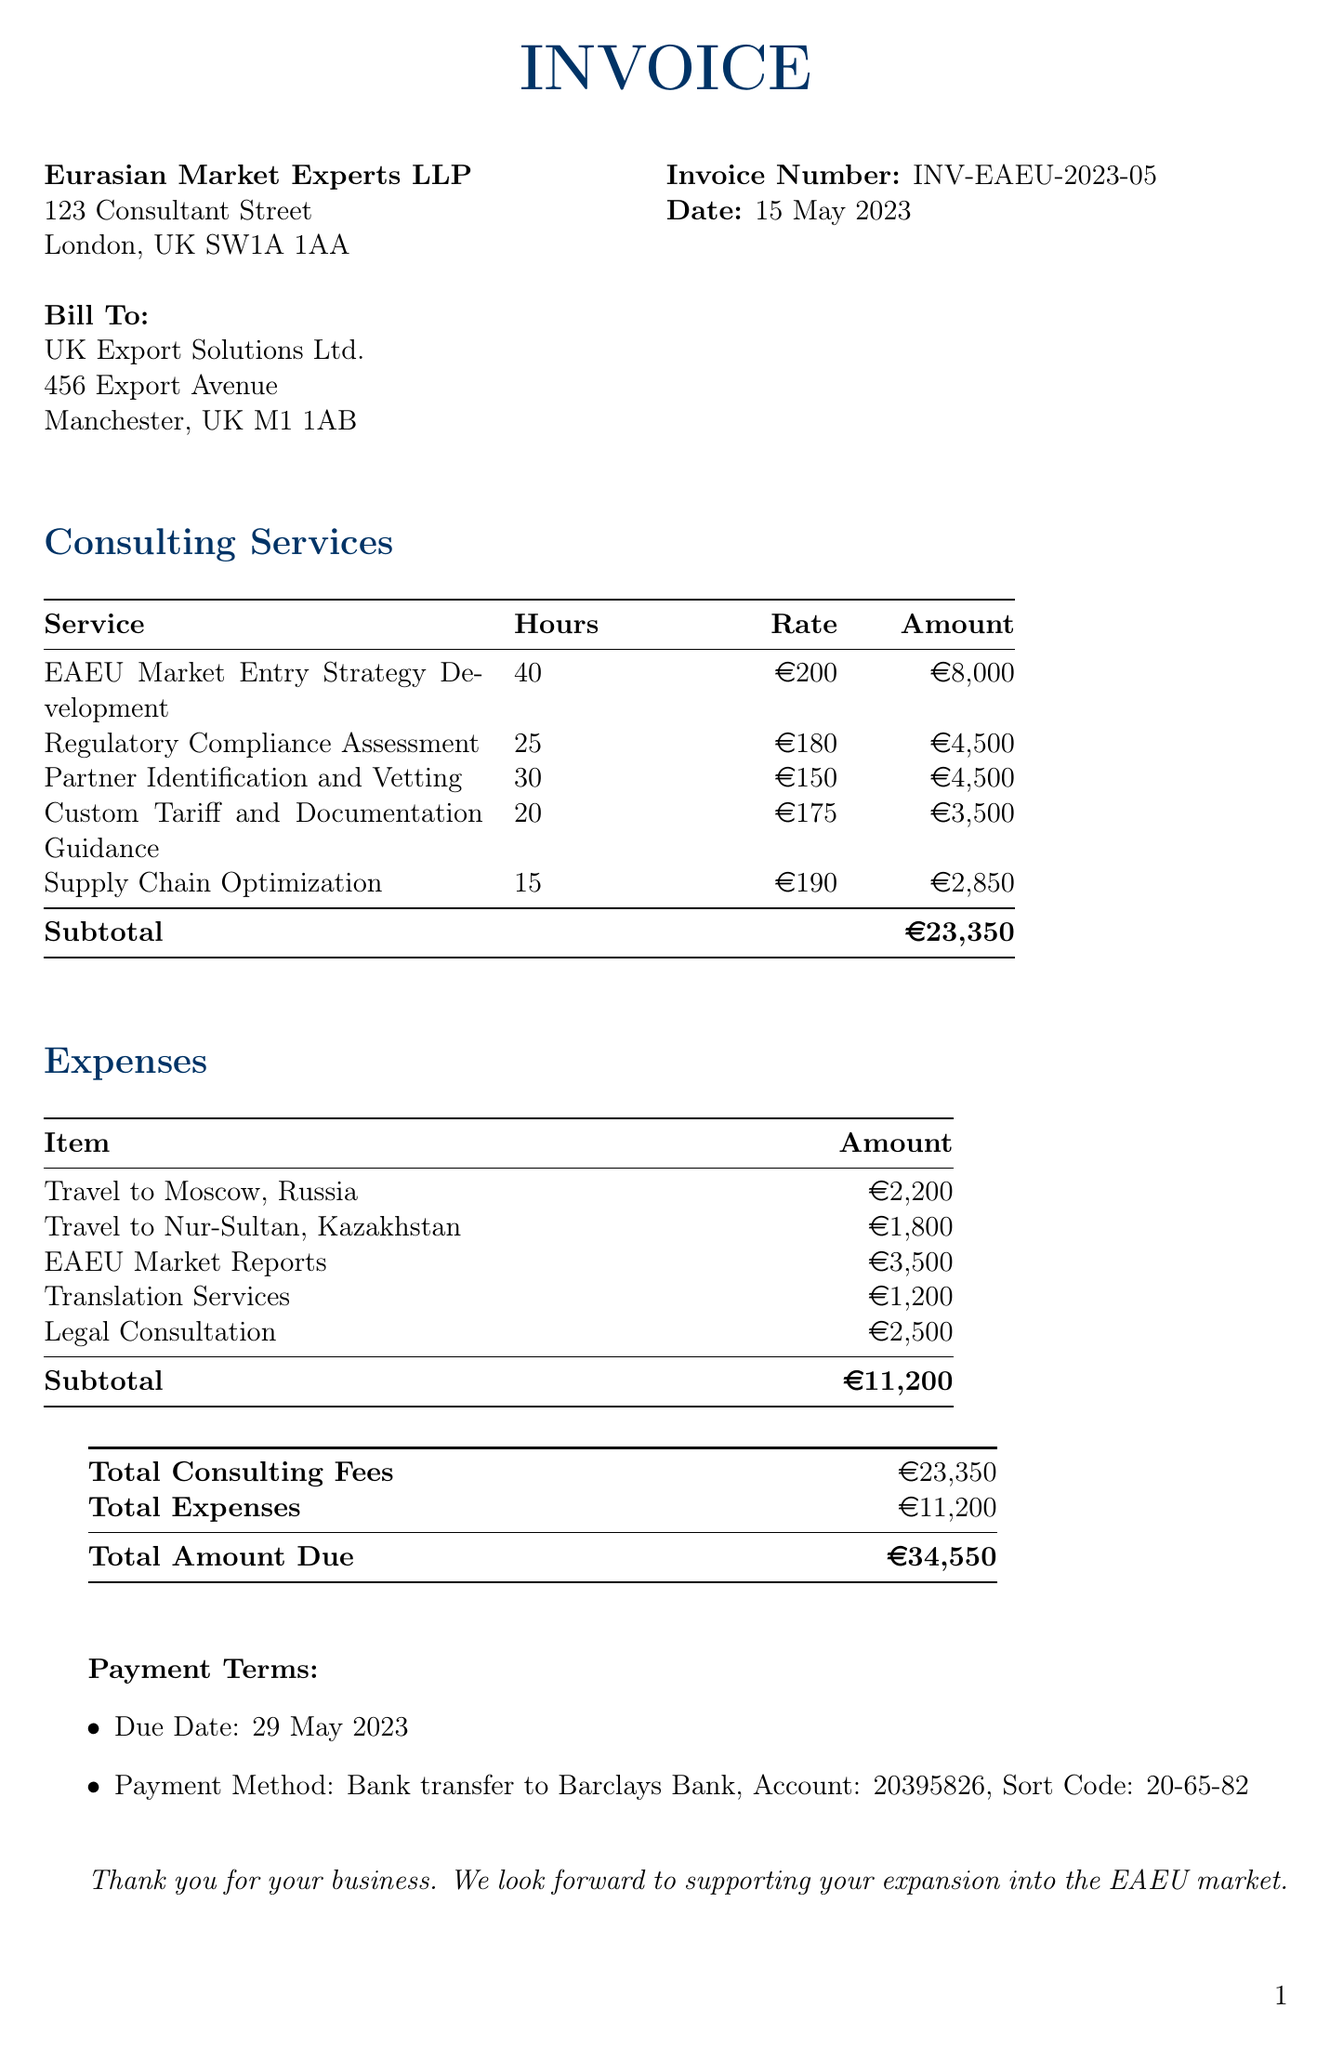What is the client name? The client name is listed in the "Bill To" section as UK Export Solutions Ltd.
Answer: UK Export Solutions Ltd What is the total amount due? The total amount due is indicated at the bottom of the invoice, which combines consulting fees and expenses.
Answer: 34,550 What is the date of the invoice? The date of the invoice can be found in the header section of the document.
Answer: 15 May 2023 How many hours were spent on the Regulatory Compliance Assessment? The number of hours spent on this service is detailed in the Consulting Services section.
Answer: 25 What is the payment due date? The payment due date is specified in the Payment Terms section.
Answer: 29 May 2023 What is the hourly rate for the EAEU Market Entry Strategy Development? The hourly rate for this service is outlined in the Consulting Services table.
Answer: 200 What is the amount for the translation services? The amount for translation services is listed in the Expenses section.
Answer: 1,200 How many total consulting services are listed? The document lists the number of services provided in the Consulting Services section.
Answer: 5 